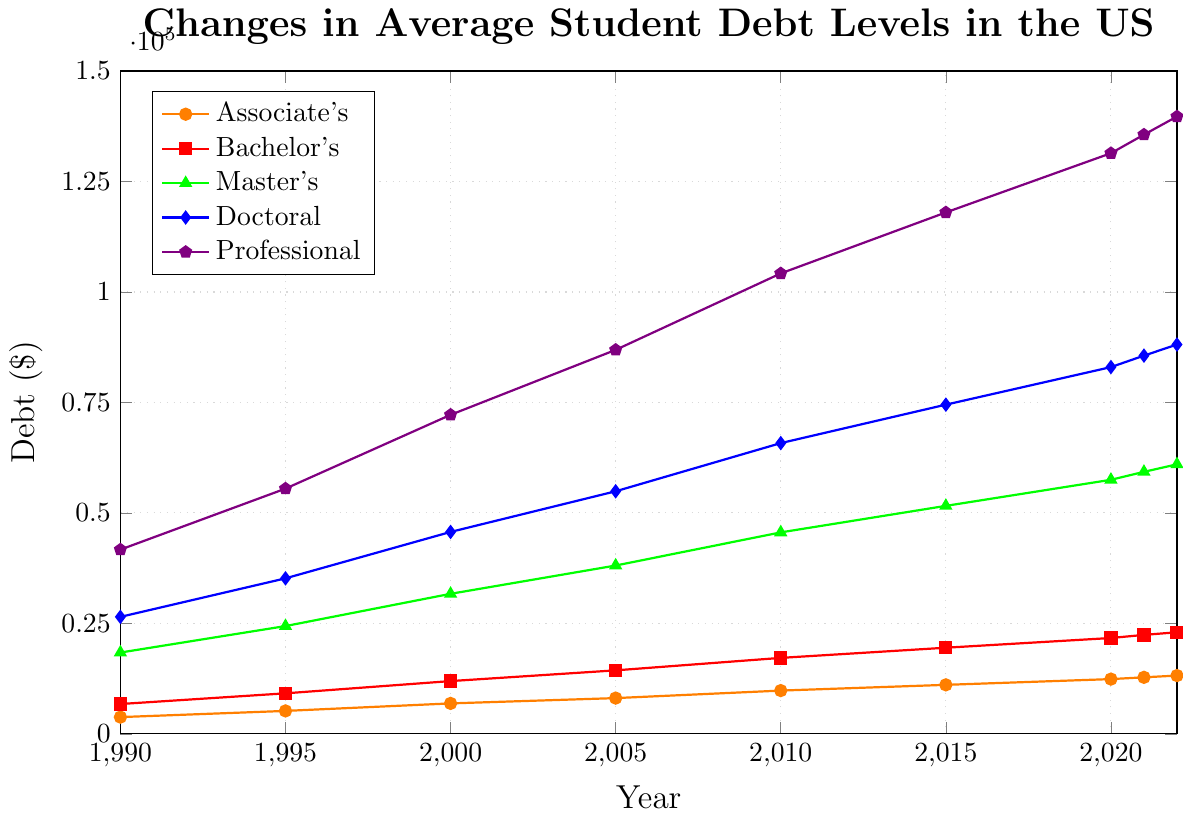What is the student debt level for a Master's degree in the year 2020? Locate the Master's degree line (green) on the chart and find the data point corresponding to the year 2020. The value should be directly read off the y-axis.
Answer: $57,500 Which degree type had the highest student debt level in 2022? Look at the end of the plot for the year 2022 and identify the line that reaches the highest point on the y-axis. The Professional degree (purple) line is the highest.
Answer: Professional By how much did the doctoral student debt level increase from 1995 to 2005? Locate the Doctoral degree line (blue) and find the values for the years 1995 and 2005. Subtract the 1995 value from the 2005 value: 54,900 - 35,200 = 19,700.
Answer: $19,700 How does the average student debt for Bachelor's degrees in 2022 compare to that in 1990? Identify the Bachelor's degree line (red) and find the values for the years 1990 and 2022. Compare the two values: 23,000 in 2022 and 6,760 in 1990.
Answer: Increased Which degree type experienced the largest absolute increase in student debt from 1990 to 2022? For each degree type, calculate the increase from 1990 to 2022 by identifying the values for those years and then subtracting the 1990 value from the 2022 value. The Professional degree shows the largest increase: 139,700 - 41,700 = 98,000.
Answer: Professional What is the average student debt level in 2015 for all degree types? Find the debt levels for each degree type in 2015 and calculate their average: (11,100 + 19,500 + 51,600 + 74,500 + 118,000) / 5 = 54,140.
Answer: $54,140 What is the difference in student debt levels between a Bachelor's and Professional degree in 2010? Identify the Bachelor's (red) and Professional (purple) lines in 2010, then subtract the Bachelor's debt from the Professional debt: 104,200 - 17,200 = 87,000.
Answer: $87,000 Which degree type had the lowest student debt level in 2000? Locate the year 2000 on the chart and find the lowest y-axis value among the degree types. The Associate's degree (orange) has the lowest value at 6,900.
Answer: Associate's 